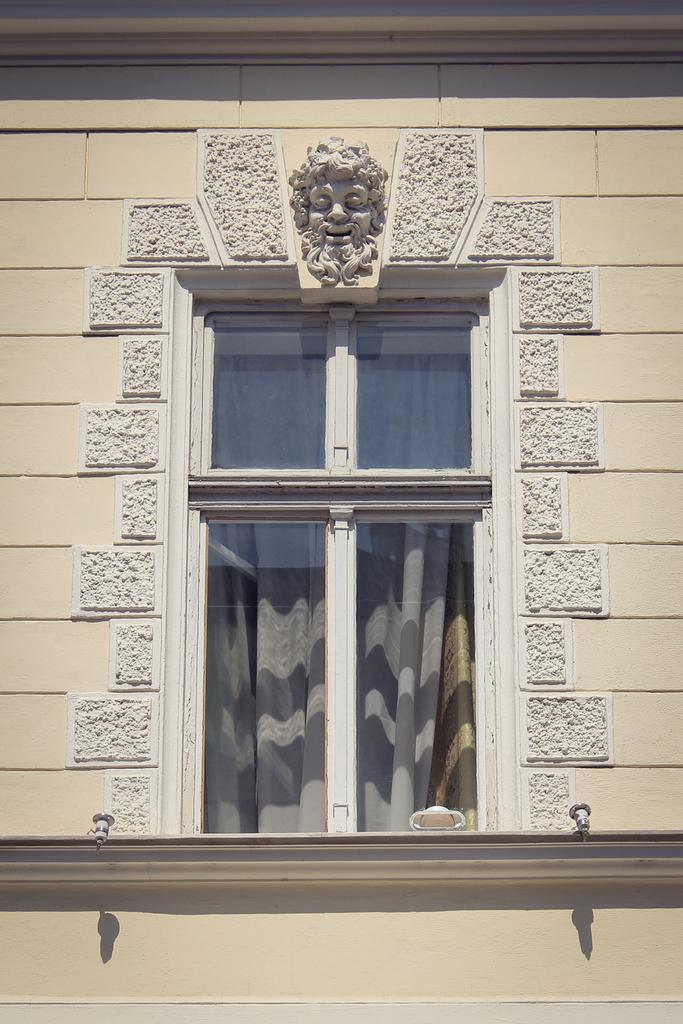What is present on the wall in the image? There is a window and a face crafted on the wall in the image. Can you describe the window in the image? The window is on a wall, and there is a curtain associated with it. What might be used to cover or uncover the window in the image? The curtain associated with the window can be used to cover or uncover it. How many cups are visible in the image? There are no cups present in the image. What type of riddle can be solved by looking at the face crafted on the wall in the image? There is no riddle associated with the face crafted on the wall in the image. 